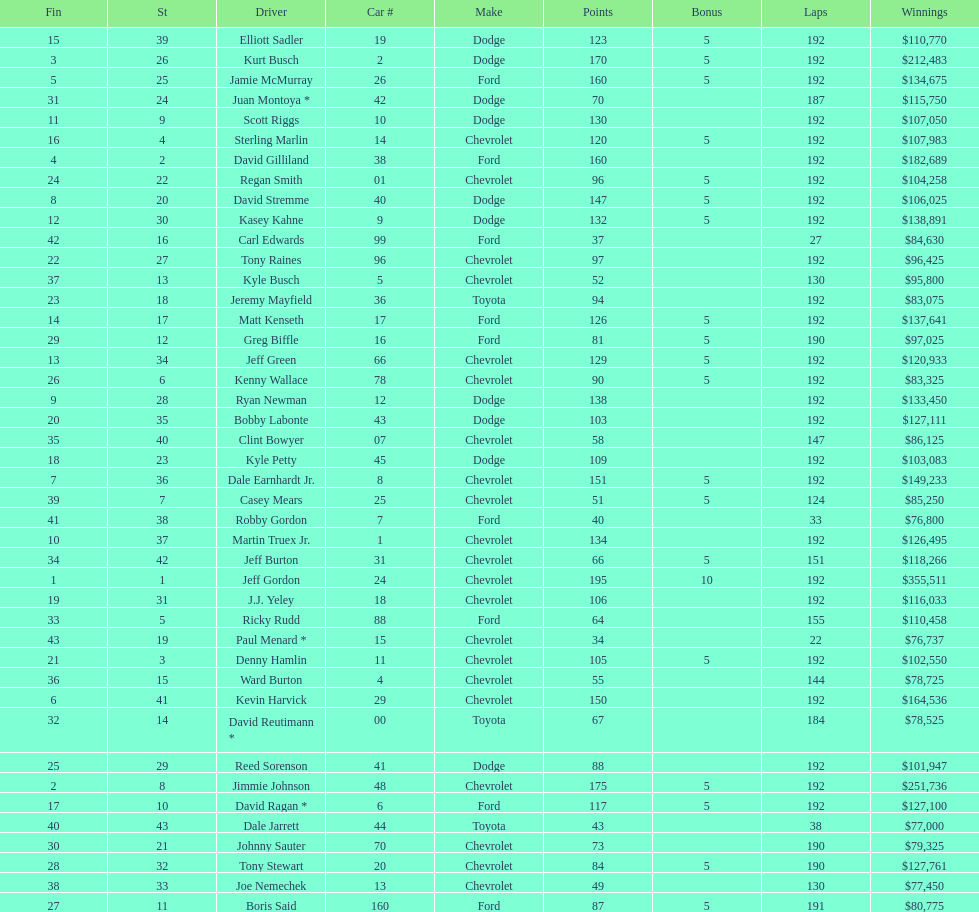What was the make of both jeff gordon's and jimmie johnson's race car? Chevrolet. 